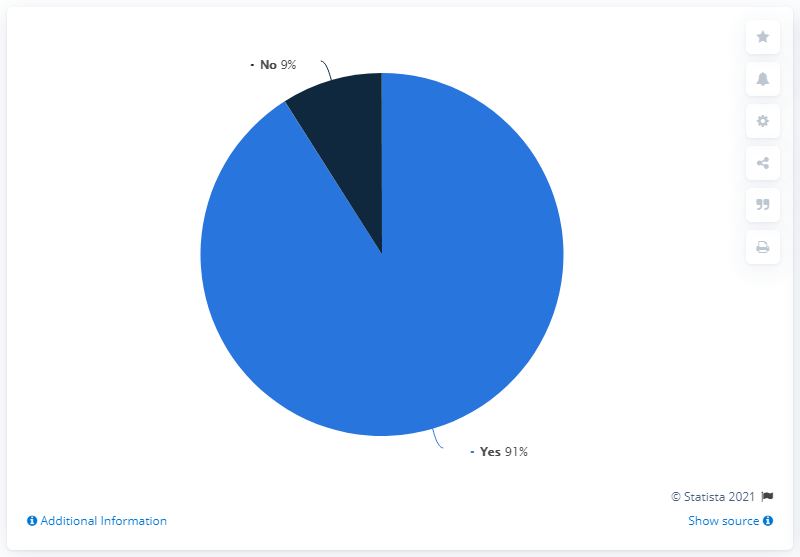Identify some key points in this picture. The large segment makes a degree of 91 The division of the Yes scenario percent by the No scenario percent, and then adding the result to the latter scenario percent, gives a final value of 19.1. 